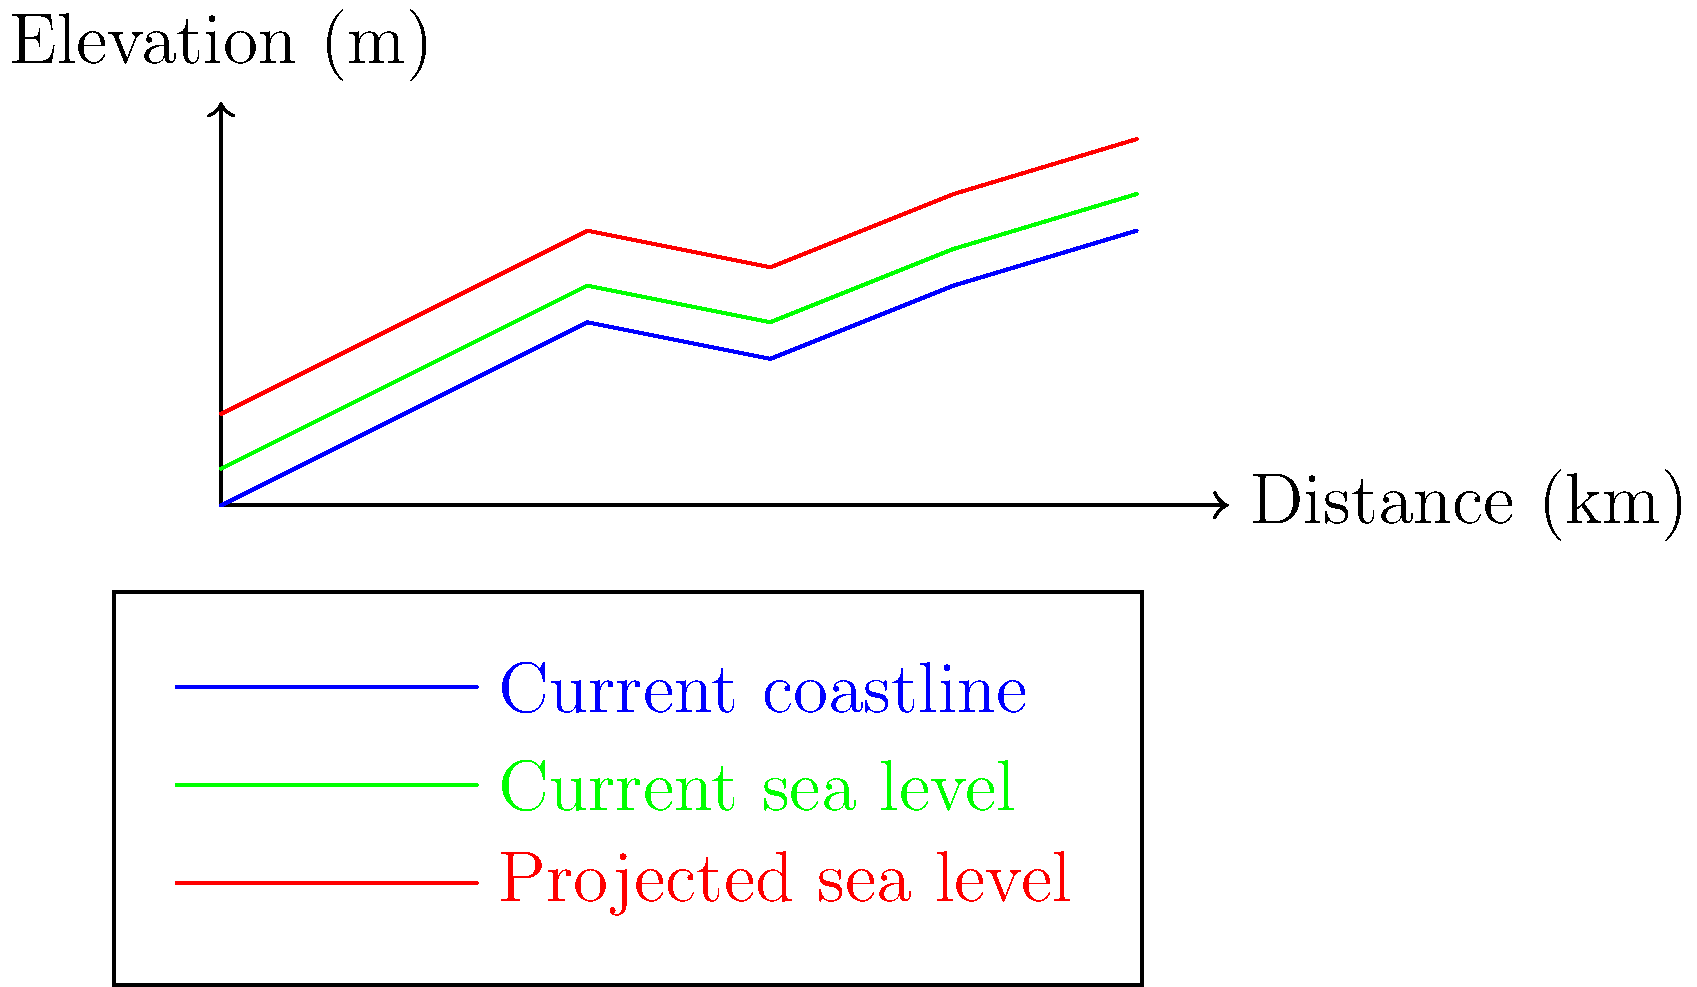Based on the map visualization of sea level rise projections for a coastal area, what is the approximate maximum increase in sea level expected according to the projection? To determine the maximum increase in sea level from the current level to the projected level:

1. Examine the graph, noting the green line (current sea level) and red line (projected sea level).
2. Find the point where the gap between these lines is largest.
3. This occurs at the right end of the graph (5 km distance).
4. At this point, the current sea level is at about 1.7 m elevation.
5. The projected sea level at the same point is at about 2.0 m elevation.
6. Calculate the difference: $2.0 \text{ m} - 1.7 \text{ m} = 0.3 \text{ m}$

Therefore, the maximum increase in sea level expected is approximately 0.3 meters.
Answer: 0.3 meters 